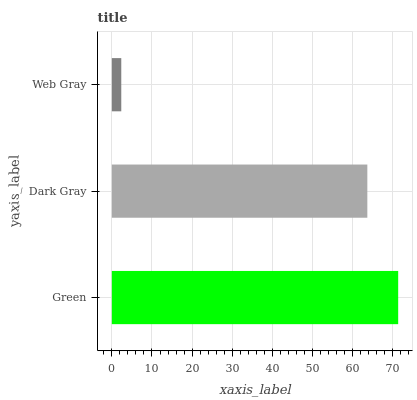Is Web Gray the minimum?
Answer yes or no. Yes. Is Green the maximum?
Answer yes or no. Yes. Is Dark Gray the minimum?
Answer yes or no. No. Is Dark Gray the maximum?
Answer yes or no. No. Is Green greater than Dark Gray?
Answer yes or no. Yes. Is Dark Gray less than Green?
Answer yes or no. Yes. Is Dark Gray greater than Green?
Answer yes or no. No. Is Green less than Dark Gray?
Answer yes or no. No. Is Dark Gray the high median?
Answer yes or no. Yes. Is Dark Gray the low median?
Answer yes or no. Yes. Is Green the high median?
Answer yes or no. No. Is Web Gray the low median?
Answer yes or no. No. 